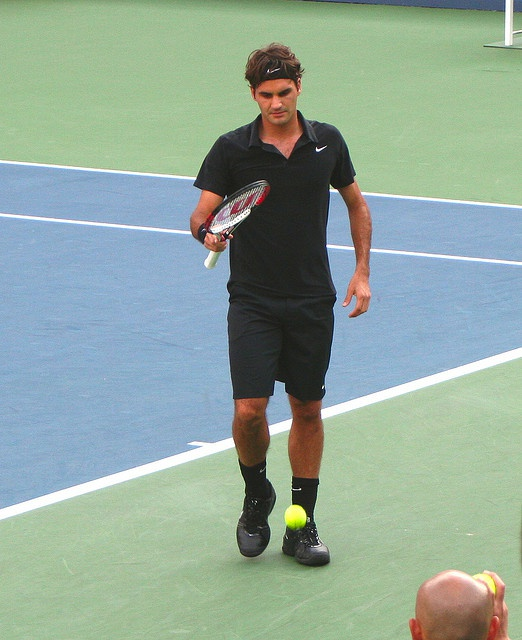Describe the objects in this image and their specific colors. I can see people in olive, black, maroon, brown, and gray tones, tennis racket in olive, white, darkgray, gray, and black tones, sports ball in olive, yellow, khaki, and lime tones, and sports ball in olive, khaki, lightyellow, and yellow tones in this image. 